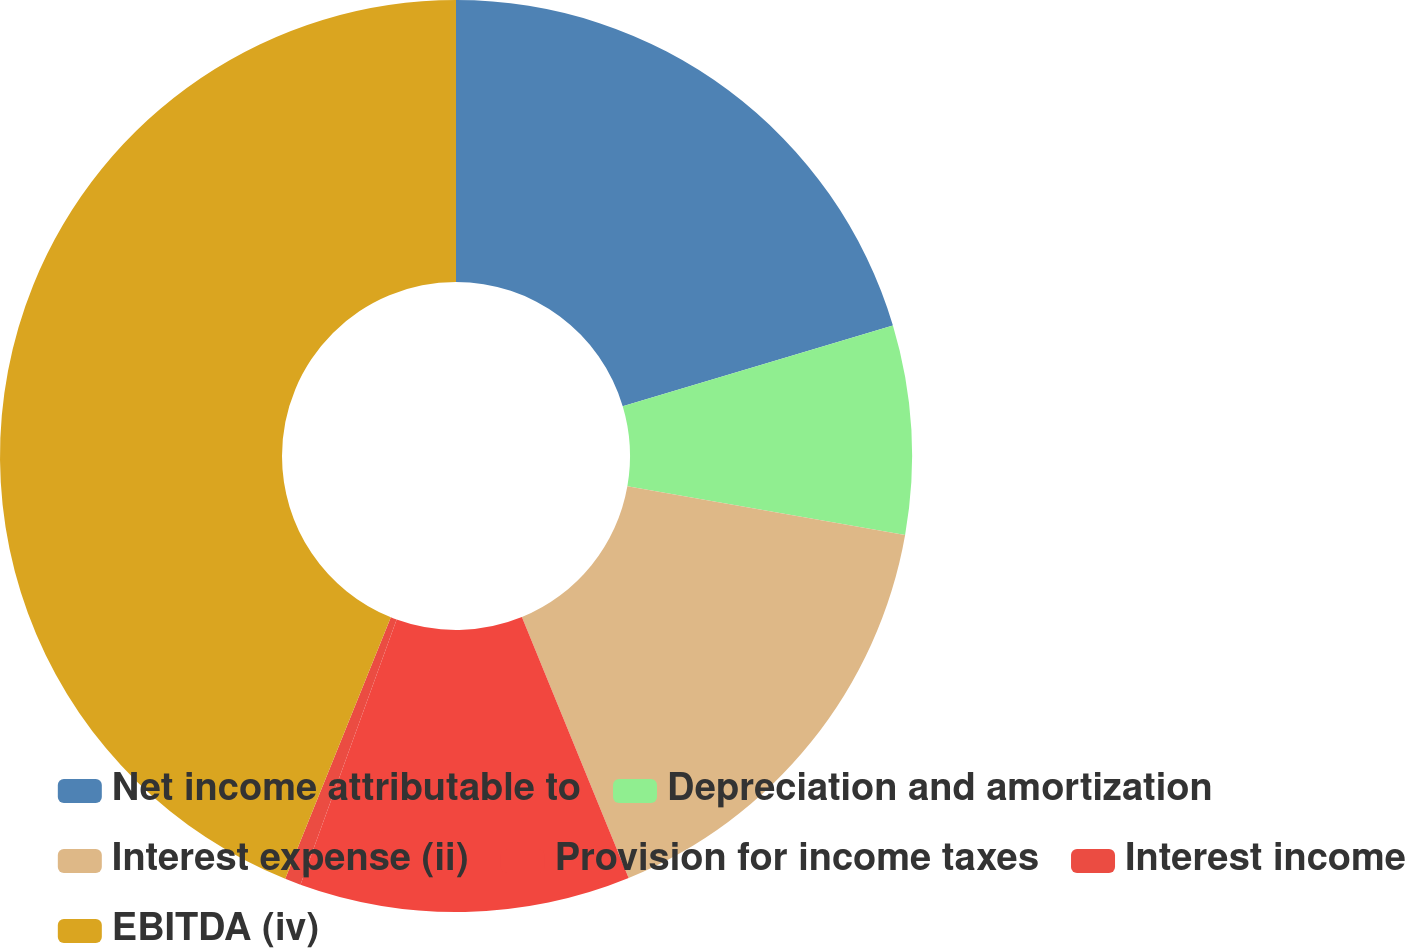Convert chart. <chart><loc_0><loc_0><loc_500><loc_500><pie_chart><fcel>Net income attributable to<fcel>Depreciation and amortization<fcel>Interest expense (ii)<fcel>Provision for income taxes<fcel>Interest income<fcel>EBITDA (iv)<nl><fcel>20.38%<fcel>7.39%<fcel>16.05%<fcel>11.72%<fcel>0.57%<fcel>43.89%<nl></chart> 